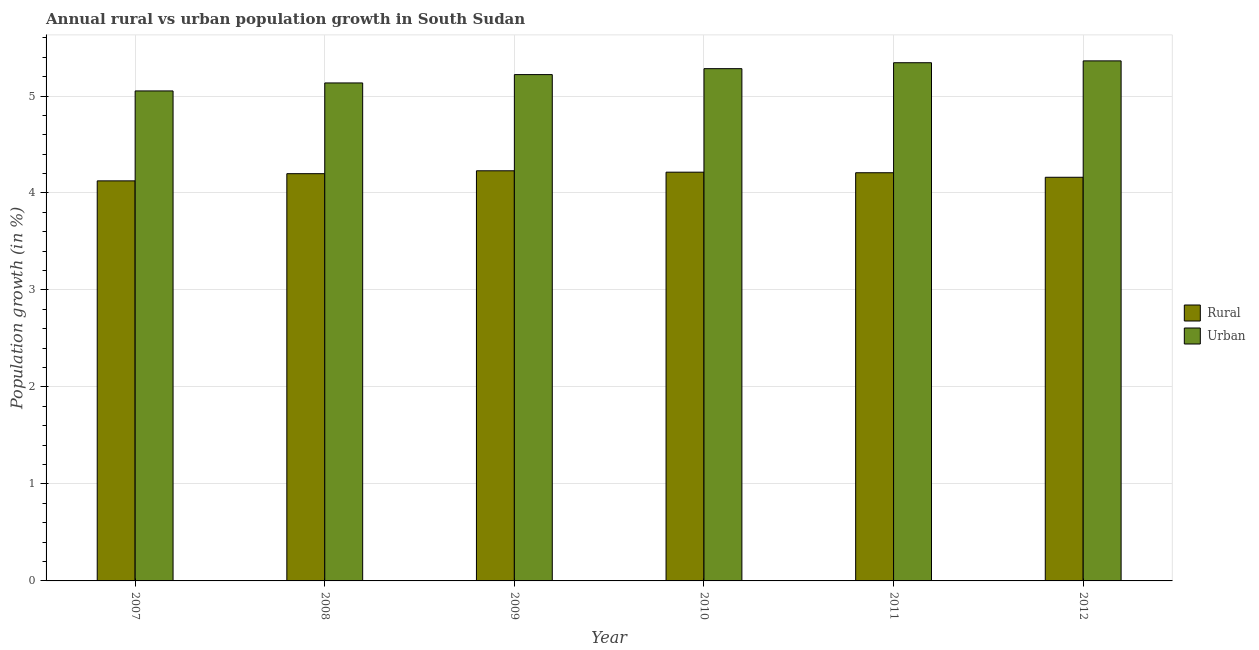How many groups of bars are there?
Your response must be concise. 6. Are the number of bars per tick equal to the number of legend labels?
Give a very brief answer. Yes. What is the label of the 4th group of bars from the left?
Your answer should be compact. 2010. In how many cases, is the number of bars for a given year not equal to the number of legend labels?
Ensure brevity in your answer.  0. What is the urban population growth in 2007?
Your response must be concise. 5.05. Across all years, what is the maximum rural population growth?
Offer a very short reply. 4.23. Across all years, what is the minimum rural population growth?
Your response must be concise. 4.12. What is the total urban population growth in the graph?
Your response must be concise. 31.39. What is the difference between the rural population growth in 2008 and that in 2011?
Offer a terse response. -0.01. What is the difference between the rural population growth in 2012 and the urban population growth in 2010?
Your answer should be compact. -0.05. What is the average rural population growth per year?
Provide a short and direct response. 4.19. In the year 2009, what is the difference between the urban population growth and rural population growth?
Ensure brevity in your answer.  0. What is the ratio of the rural population growth in 2007 to that in 2009?
Provide a short and direct response. 0.98. What is the difference between the highest and the second highest rural population growth?
Ensure brevity in your answer.  0.01. What is the difference between the highest and the lowest rural population growth?
Provide a short and direct response. 0.1. Is the sum of the urban population growth in 2007 and 2009 greater than the maximum rural population growth across all years?
Your response must be concise. Yes. What does the 2nd bar from the left in 2011 represents?
Provide a succinct answer. Urban . What does the 2nd bar from the right in 2011 represents?
Your response must be concise. Rural. How many bars are there?
Give a very brief answer. 12. Are all the bars in the graph horizontal?
Your response must be concise. No. How many years are there in the graph?
Your answer should be very brief. 6. Are the values on the major ticks of Y-axis written in scientific E-notation?
Give a very brief answer. No. How many legend labels are there?
Give a very brief answer. 2. What is the title of the graph?
Keep it short and to the point. Annual rural vs urban population growth in South Sudan. What is the label or title of the X-axis?
Make the answer very short. Year. What is the label or title of the Y-axis?
Offer a very short reply. Population growth (in %). What is the Population growth (in %) of Rural in 2007?
Give a very brief answer. 4.12. What is the Population growth (in %) in Urban  in 2007?
Your answer should be compact. 5.05. What is the Population growth (in %) in Rural in 2008?
Make the answer very short. 4.2. What is the Population growth (in %) of Urban  in 2008?
Your answer should be compact. 5.13. What is the Population growth (in %) in Rural in 2009?
Give a very brief answer. 4.23. What is the Population growth (in %) of Urban  in 2009?
Your response must be concise. 5.22. What is the Population growth (in %) of Rural in 2010?
Offer a terse response. 4.21. What is the Population growth (in %) in Urban  in 2010?
Provide a short and direct response. 5.28. What is the Population growth (in %) in Rural in 2011?
Make the answer very short. 4.21. What is the Population growth (in %) in Urban  in 2011?
Ensure brevity in your answer.  5.34. What is the Population growth (in %) in Rural in 2012?
Your answer should be very brief. 4.16. What is the Population growth (in %) of Urban  in 2012?
Give a very brief answer. 5.36. Across all years, what is the maximum Population growth (in %) in Rural?
Your answer should be compact. 4.23. Across all years, what is the maximum Population growth (in %) in Urban ?
Your answer should be compact. 5.36. Across all years, what is the minimum Population growth (in %) in Rural?
Your answer should be very brief. 4.12. Across all years, what is the minimum Population growth (in %) of Urban ?
Give a very brief answer. 5.05. What is the total Population growth (in %) in Rural in the graph?
Provide a short and direct response. 25.14. What is the total Population growth (in %) of Urban  in the graph?
Provide a short and direct response. 31.39. What is the difference between the Population growth (in %) of Rural in 2007 and that in 2008?
Your response must be concise. -0.07. What is the difference between the Population growth (in %) of Urban  in 2007 and that in 2008?
Ensure brevity in your answer.  -0.08. What is the difference between the Population growth (in %) in Rural in 2007 and that in 2009?
Offer a very short reply. -0.1. What is the difference between the Population growth (in %) of Urban  in 2007 and that in 2009?
Your answer should be compact. -0.17. What is the difference between the Population growth (in %) in Rural in 2007 and that in 2010?
Provide a succinct answer. -0.09. What is the difference between the Population growth (in %) of Urban  in 2007 and that in 2010?
Offer a terse response. -0.23. What is the difference between the Population growth (in %) in Rural in 2007 and that in 2011?
Provide a succinct answer. -0.08. What is the difference between the Population growth (in %) in Urban  in 2007 and that in 2011?
Give a very brief answer. -0.29. What is the difference between the Population growth (in %) of Rural in 2007 and that in 2012?
Provide a short and direct response. -0.04. What is the difference between the Population growth (in %) of Urban  in 2007 and that in 2012?
Offer a terse response. -0.31. What is the difference between the Population growth (in %) in Rural in 2008 and that in 2009?
Keep it short and to the point. -0.03. What is the difference between the Population growth (in %) in Urban  in 2008 and that in 2009?
Make the answer very short. -0.09. What is the difference between the Population growth (in %) of Rural in 2008 and that in 2010?
Offer a very short reply. -0.02. What is the difference between the Population growth (in %) in Urban  in 2008 and that in 2010?
Ensure brevity in your answer.  -0.15. What is the difference between the Population growth (in %) of Rural in 2008 and that in 2011?
Your response must be concise. -0.01. What is the difference between the Population growth (in %) of Urban  in 2008 and that in 2011?
Keep it short and to the point. -0.21. What is the difference between the Population growth (in %) of Rural in 2008 and that in 2012?
Offer a very short reply. 0.04. What is the difference between the Population growth (in %) in Urban  in 2008 and that in 2012?
Provide a short and direct response. -0.23. What is the difference between the Population growth (in %) of Rural in 2009 and that in 2010?
Give a very brief answer. 0.01. What is the difference between the Population growth (in %) in Urban  in 2009 and that in 2010?
Offer a terse response. -0.06. What is the difference between the Population growth (in %) in Rural in 2009 and that in 2011?
Make the answer very short. 0.02. What is the difference between the Population growth (in %) of Urban  in 2009 and that in 2011?
Your response must be concise. -0.12. What is the difference between the Population growth (in %) in Rural in 2009 and that in 2012?
Give a very brief answer. 0.07. What is the difference between the Population growth (in %) in Urban  in 2009 and that in 2012?
Provide a succinct answer. -0.14. What is the difference between the Population growth (in %) of Rural in 2010 and that in 2011?
Your answer should be very brief. 0.01. What is the difference between the Population growth (in %) in Urban  in 2010 and that in 2011?
Your answer should be very brief. -0.06. What is the difference between the Population growth (in %) of Rural in 2010 and that in 2012?
Keep it short and to the point. 0.05. What is the difference between the Population growth (in %) in Urban  in 2010 and that in 2012?
Provide a succinct answer. -0.08. What is the difference between the Population growth (in %) in Rural in 2011 and that in 2012?
Provide a succinct answer. 0.05. What is the difference between the Population growth (in %) of Urban  in 2011 and that in 2012?
Give a very brief answer. -0.02. What is the difference between the Population growth (in %) in Rural in 2007 and the Population growth (in %) in Urban  in 2008?
Offer a terse response. -1.01. What is the difference between the Population growth (in %) in Rural in 2007 and the Population growth (in %) in Urban  in 2009?
Ensure brevity in your answer.  -1.1. What is the difference between the Population growth (in %) of Rural in 2007 and the Population growth (in %) of Urban  in 2010?
Make the answer very short. -1.16. What is the difference between the Population growth (in %) in Rural in 2007 and the Population growth (in %) in Urban  in 2011?
Your answer should be very brief. -1.22. What is the difference between the Population growth (in %) in Rural in 2007 and the Population growth (in %) in Urban  in 2012?
Your answer should be compact. -1.24. What is the difference between the Population growth (in %) of Rural in 2008 and the Population growth (in %) of Urban  in 2009?
Your answer should be very brief. -1.02. What is the difference between the Population growth (in %) in Rural in 2008 and the Population growth (in %) in Urban  in 2010?
Give a very brief answer. -1.08. What is the difference between the Population growth (in %) in Rural in 2008 and the Population growth (in %) in Urban  in 2011?
Your response must be concise. -1.14. What is the difference between the Population growth (in %) in Rural in 2008 and the Population growth (in %) in Urban  in 2012?
Your answer should be compact. -1.16. What is the difference between the Population growth (in %) in Rural in 2009 and the Population growth (in %) in Urban  in 2010?
Offer a very short reply. -1.05. What is the difference between the Population growth (in %) of Rural in 2009 and the Population growth (in %) of Urban  in 2011?
Offer a terse response. -1.11. What is the difference between the Population growth (in %) in Rural in 2009 and the Population growth (in %) in Urban  in 2012?
Keep it short and to the point. -1.13. What is the difference between the Population growth (in %) of Rural in 2010 and the Population growth (in %) of Urban  in 2011?
Make the answer very short. -1.13. What is the difference between the Population growth (in %) of Rural in 2010 and the Population growth (in %) of Urban  in 2012?
Your answer should be very brief. -1.15. What is the difference between the Population growth (in %) of Rural in 2011 and the Population growth (in %) of Urban  in 2012?
Your answer should be compact. -1.15. What is the average Population growth (in %) of Rural per year?
Offer a terse response. 4.19. What is the average Population growth (in %) of Urban  per year?
Ensure brevity in your answer.  5.23. In the year 2007, what is the difference between the Population growth (in %) of Rural and Population growth (in %) of Urban ?
Provide a succinct answer. -0.93. In the year 2008, what is the difference between the Population growth (in %) of Rural and Population growth (in %) of Urban ?
Provide a succinct answer. -0.94. In the year 2009, what is the difference between the Population growth (in %) of Rural and Population growth (in %) of Urban ?
Make the answer very short. -0.99. In the year 2010, what is the difference between the Population growth (in %) of Rural and Population growth (in %) of Urban ?
Offer a very short reply. -1.07. In the year 2011, what is the difference between the Population growth (in %) in Rural and Population growth (in %) in Urban ?
Offer a terse response. -1.13. In the year 2012, what is the difference between the Population growth (in %) in Rural and Population growth (in %) in Urban ?
Make the answer very short. -1.2. What is the ratio of the Population growth (in %) in Rural in 2007 to that in 2008?
Make the answer very short. 0.98. What is the ratio of the Population growth (in %) of Urban  in 2007 to that in 2008?
Provide a short and direct response. 0.98. What is the ratio of the Population growth (in %) of Rural in 2007 to that in 2009?
Provide a short and direct response. 0.98. What is the ratio of the Population growth (in %) in Rural in 2007 to that in 2010?
Keep it short and to the point. 0.98. What is the ratio of the Population growth (in %) in Urban  in 2007 to that in 2010?
Keep it short and to the point. 0.96. What is the ratio of the Population growth (in %) of Rural in 2007 to that in 2011?
Make the answer very short. 0.98. What is the ratio of the Population growth (in %) in Urban  in 2007 to that in 2011?
Offer a very short reply. 0.95. What is the ratio of the Population growth (in %) of Rural in 2007 to that in 2012?
Provide a succinct answer. 0.99. What is the ratio of the Population growth (in %) of Urban  in 2007 to that in 2012?
Make the answer very short. 0.94. What is the ratio of the Population growth (in %) of Rural in 2008 to that in 2009?
Ensure brevity in your answer.  0.99. What is the ratio of the Population growth (in %) in Urban  in 2008 to that in 2009?
Make the answer very short. 0.98. What is the ratio of the Population growth (in %) in Urban  in 2008 to that in 2010?
Offer a very short reply. 0.97. What is the ratio of the Population growth (in %) in Rural in 2008 to that in 2011?
Your response must be concise. 1. What is the ratio of the Population growth (in %) of Rural in 2008 to that in 2012?
Offer a very short reply. 1.01. What is the ratio of the Population growth (in %) of Urban  in 2008 to that in 2012?
Make the answer very short. 0.96. What is the ratio of the Population growth (in %) of Urban  in 2009 to that in 2010?
Provide a succinct answer. 0.99. What is the ratio of the Population growth (in %) in Rural in 2009 to that in 2011?
Your answer should be very brief. 1. What is the ratio of the Population growth (in %) of Urban  in 2009 to that in 2011?
Provide a short and direct response. 0.98. What is the ratio of the Population growth (in %) of Rural in 2009 to that in 2012?
Offer a terse response. 1.02. What is the ratio of the Population growth (in %) of Urban  in 2009 to that in 2012?
Make the answer very short. 0.97. What is the ratio of the Population growth (in %) in Urban  in 2010 to that in 2011?
Offer a terse response. 0.99. What is the ratio of the Population growth (in %) in Rural in 2010 to that in 2012?
Offer a terse response. 1.01. What is the ratio of the Population growth (in %) of Urban  in 2010 to that in 2012?
Give a very brief answer. 0.98. What is the ratio of the Population growth (in %) in Rural in 2011 to that in 2012?
Give a very brief answer. 1.01. What is the difference between the highest and the second highest Population growth (in %) in Rural?
Your answer should be very brief. 0.01. What is the difference between the highest and the second highest Population growth (in %) of Urban ?
Offer a terse response. 0.02. What is the difference between the highest and the lowest Population growth (in %) in Rural?
Your response must be concise. 0.1. What is the difference between the highest and the lowest Population growth (in %) in Urban ?
Ensure brevity in your answer.  0.31. 